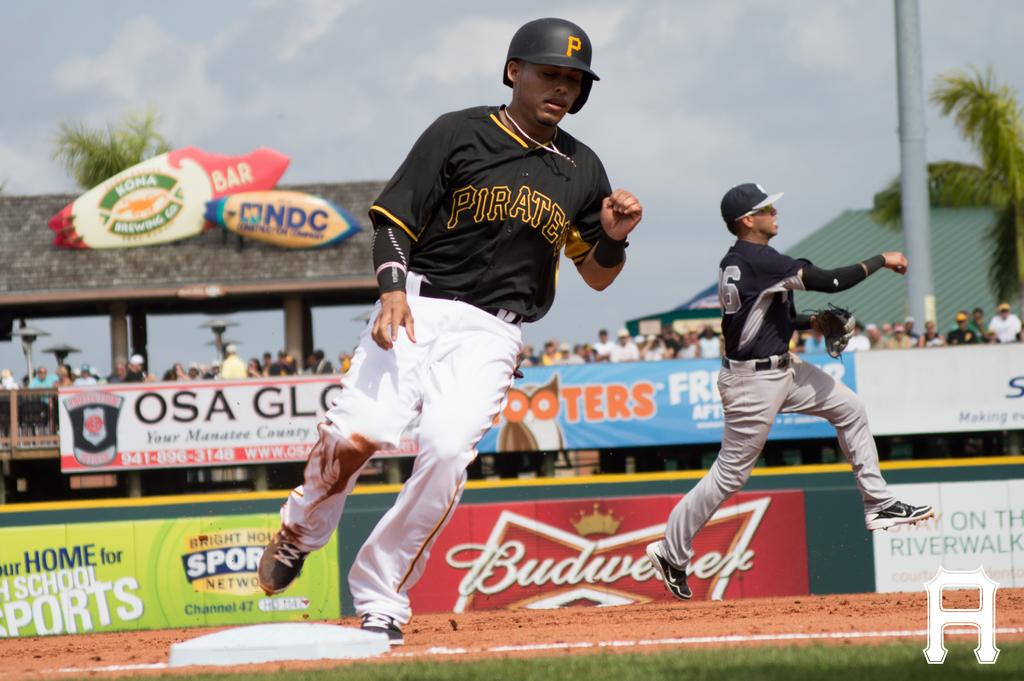<image>
Share a concise interpretation of the image provided. A base runner for the Pirates comes to third. 